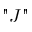<formula> <loc_0><loc_0><loc_500><loc_500>" J "</formula> 